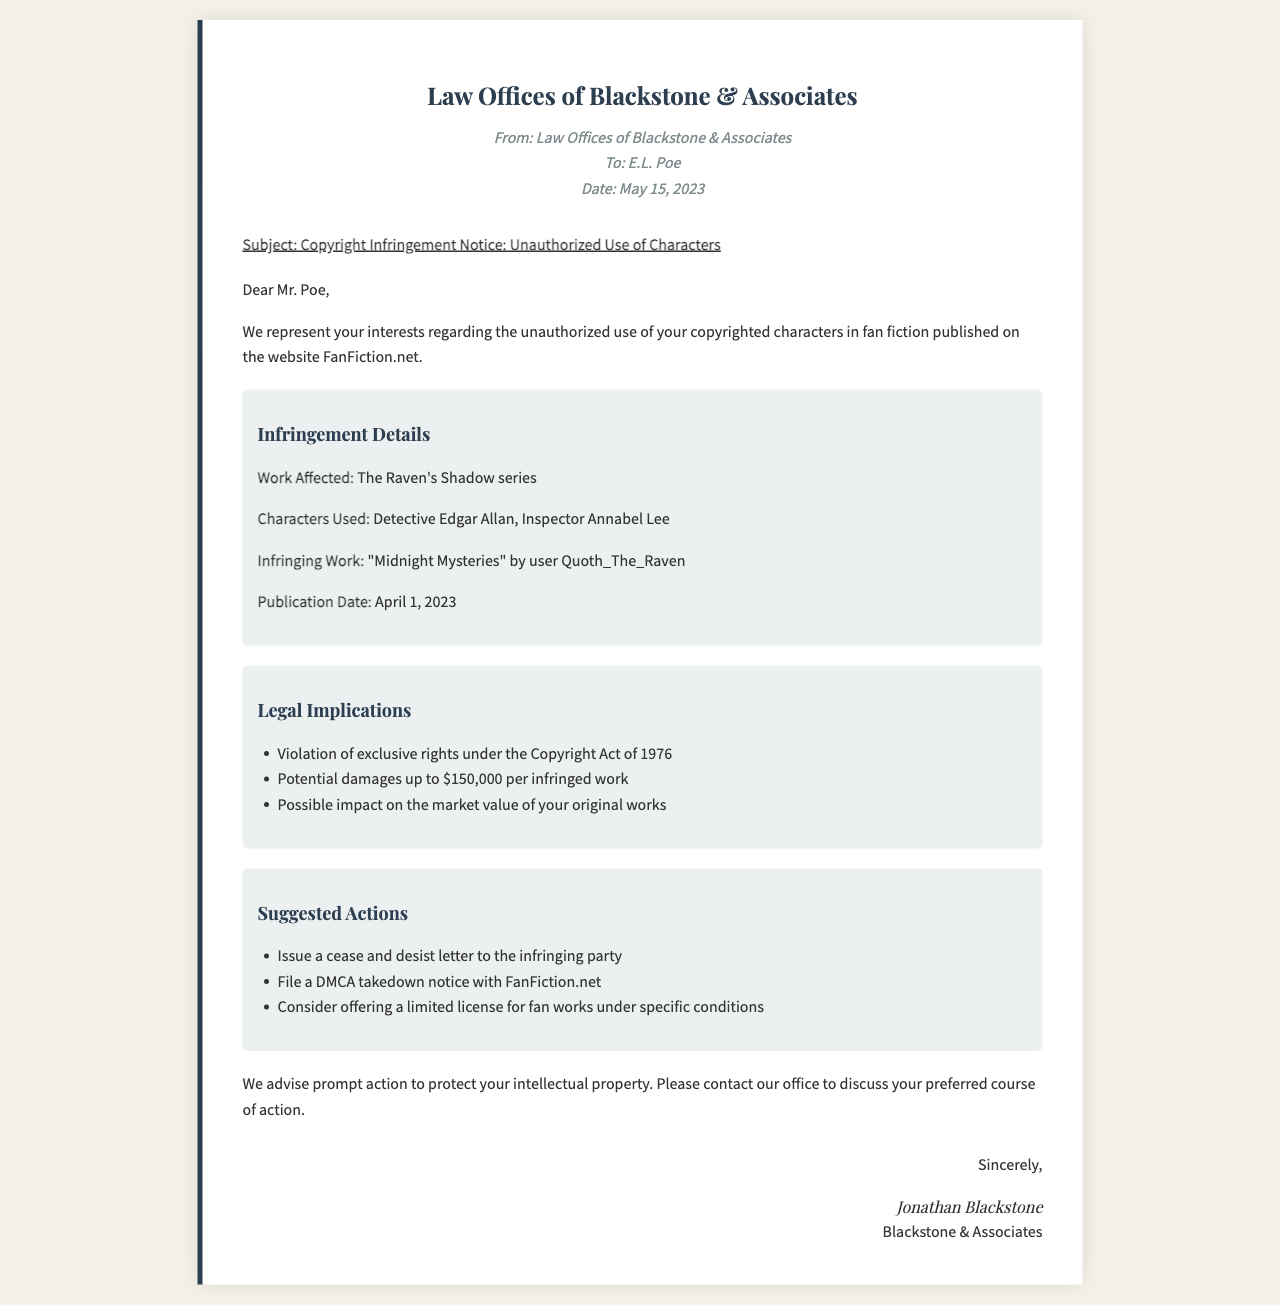What is the sender's name? The sender is identified as Law Offices of Blackstone & Associates in the document.
Answer: Law Offices of Blackstone & Associates What is the recipient's name? The recipient mentioned in the document is E.L. Poe.
Answer: E.L. Poe What is the date of the fax? The document states that the fax was sent on May 15, 2023.
Answer: May 15, 2023 What is the title of the affected work? The title of the affected work mentioned in the fax is The Raven's Shadow series.
Answer: The Raven's Shadow series What are the names of the infringing characters? The characters used without permission are Detective Edgar Allan and Inspector Annabel Lee.
Answer: Detective Edgar Allan, Inspector Annabel Lee What is the potential damage amount per infringed work? The document specifies potential damages up to $150,000 per infringed work.
Answer: $150,000 What action is suggested to the writer regarding the infringing party? The document suggests issuing a cease and desist letter to address the unauthorized use.
Answer: Issue a cease and desist letter What is the platform mentioned for the infringing work? The infringing work is published on FanFiction.net, as stated in the document.
Answer: FanFiction.net What course of action is advised for the writer? The document advises prompt action to protect intellectual property.
Answer: Prompt action 